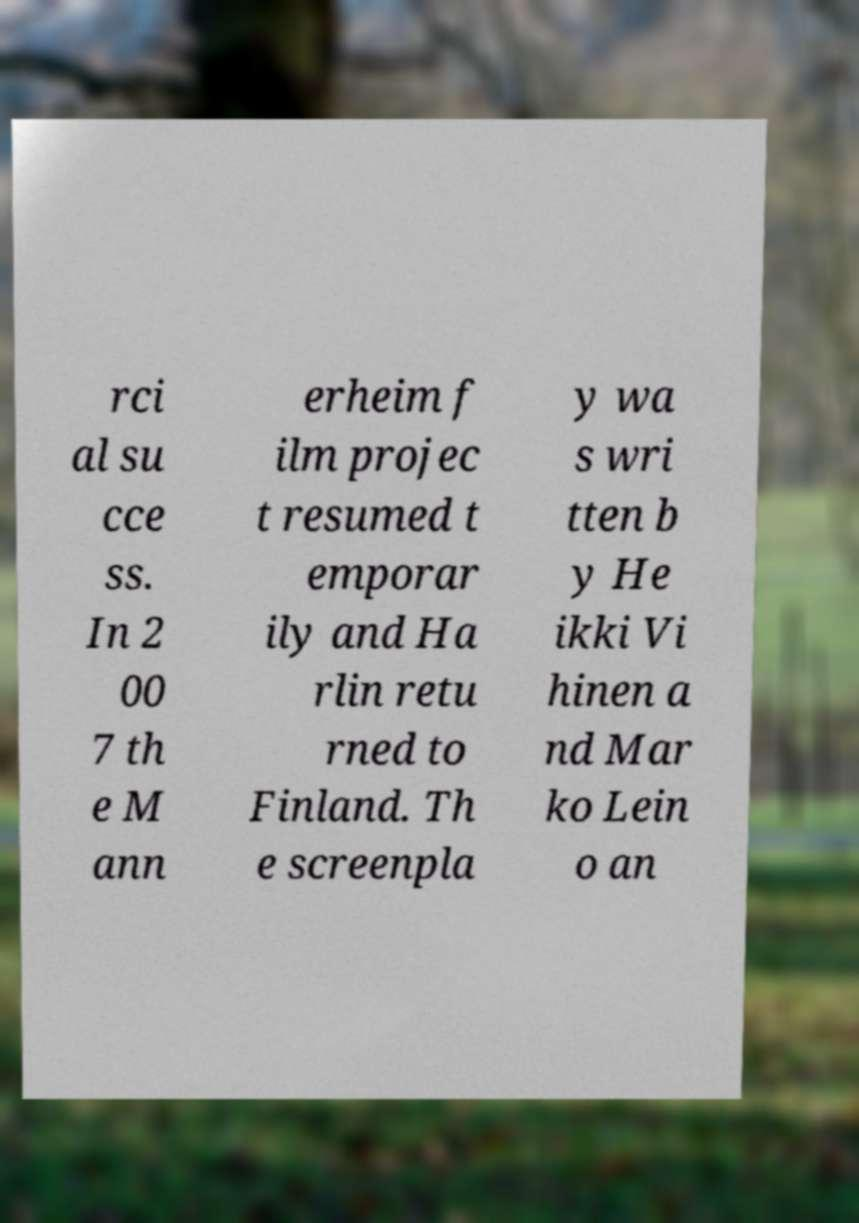I need the written content from this picture converted into text. Can you do that? rci al su cce ss. In 2 00 7 th e M ann erheim f ilm projec t resumed t emporar ily and Ha rlin retu rned to Finland. Th e screenpla y wa s wri tten b y He ikki Vi hinen a nd Mar ko Lein o an 